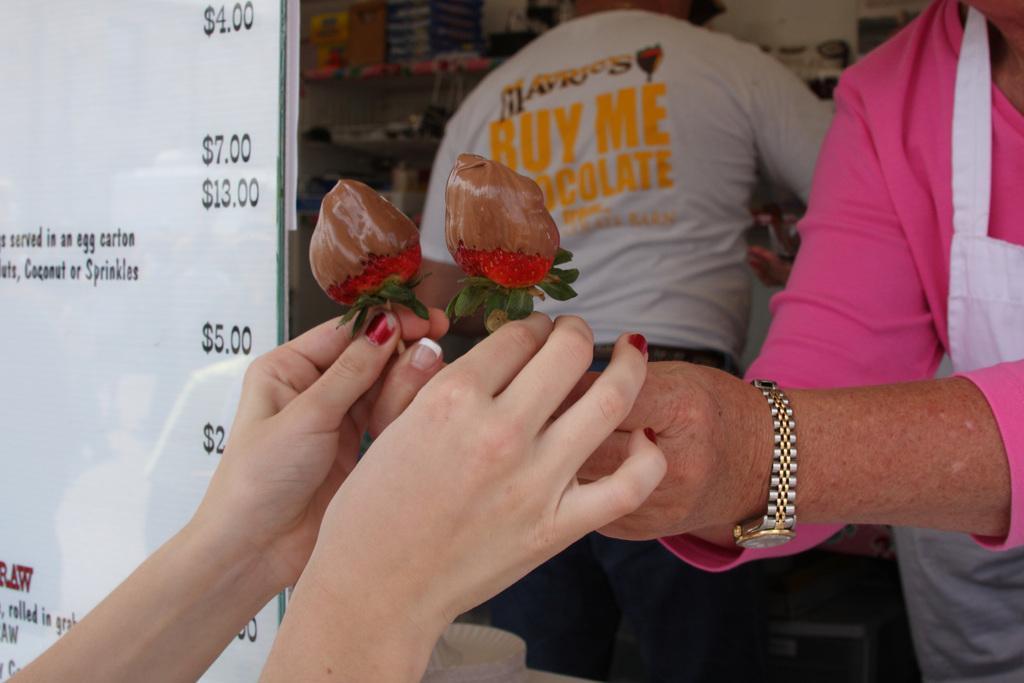How would you summarize this image in a sentence or two? In this image we can see three people, two of them are holding some food items, there is a board with some text and numbers on it, also we can see some boxes on the racks. 